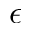Convert formula to latex. <formula><loc_0><loc_0><loc_500><loc_500>\epsilon</formula> 